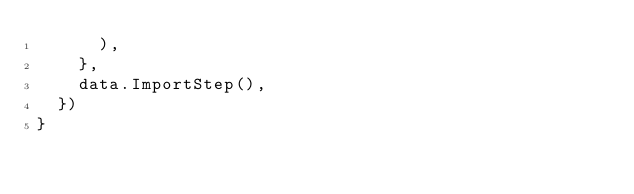Convert code to text. <code><loc_0><loc_0><loc_500><loc_500><_Go_>			),
		},
		data.ImportStep(),
	})
}
</code> 